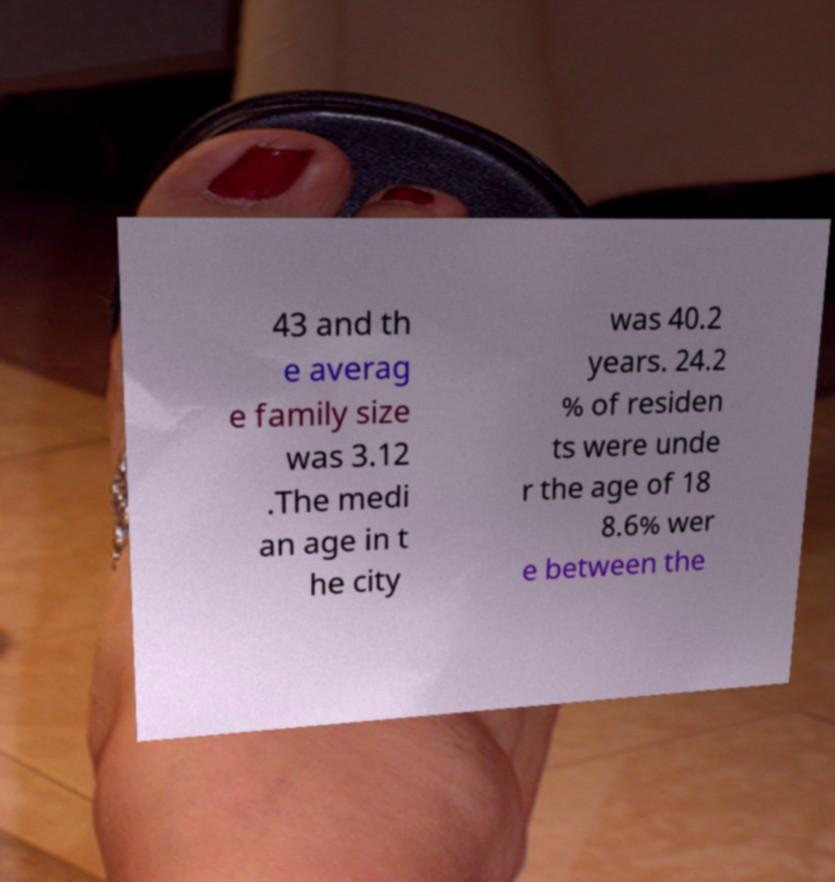Please read and relay the text visible in this image. What does it say? 43 and th e averag e family size was 3.12 .The medi an age in t he city was 40.2 years. 24.2 % of residen ts were unde r the age of 18 8.6% wer e between the 